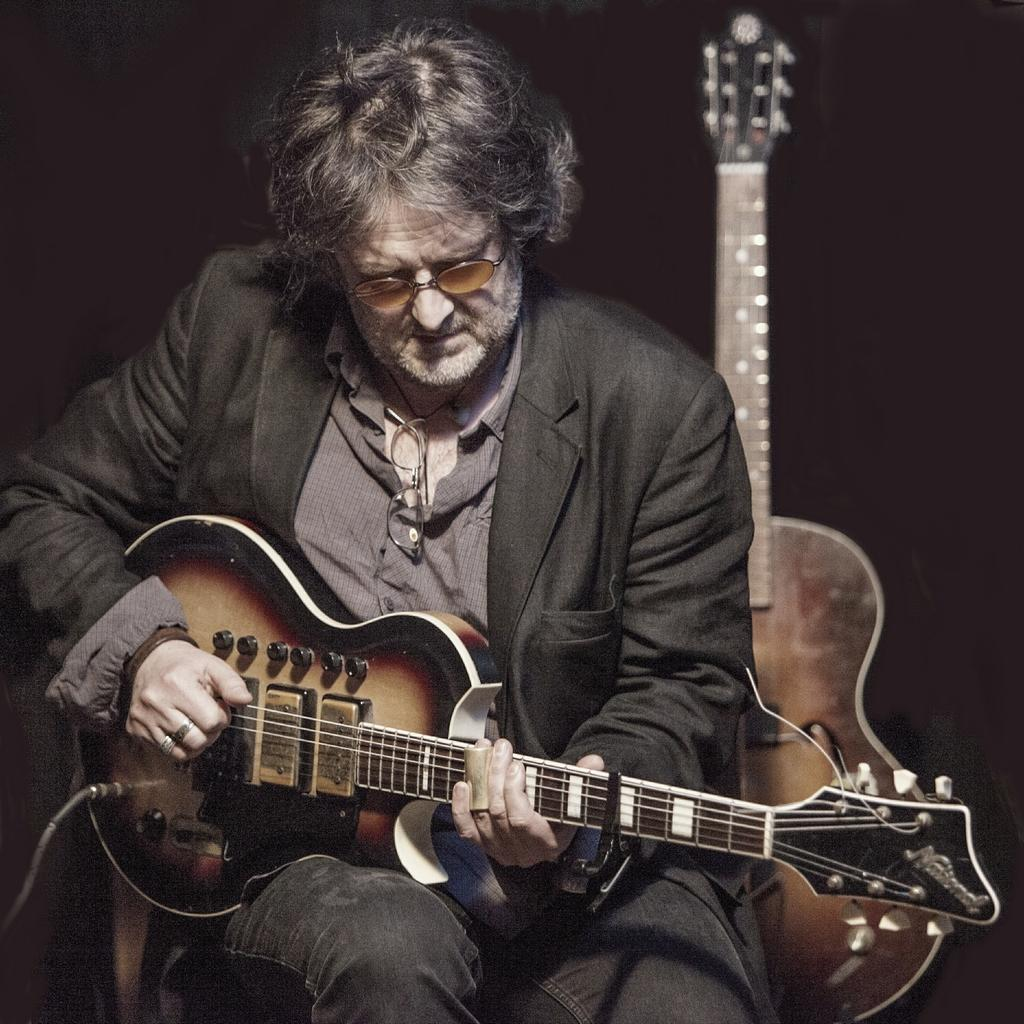Who is in the image? There is a man in the image. What is the man wearing? The man is wearing a black suit. What is the man doing in the image? The man is sitting on a chair and playing the guitar. Can you describe the other guitar in the image? There is another guitar placed behind the man. What color is the bee buzzing around the man in the image? There is no bee present in the image. What other things can be seen in the image besides the man and the guitars? The provided facts do not mention any other things in the image besides the man, the black suit, the chair, and the two guitars. 